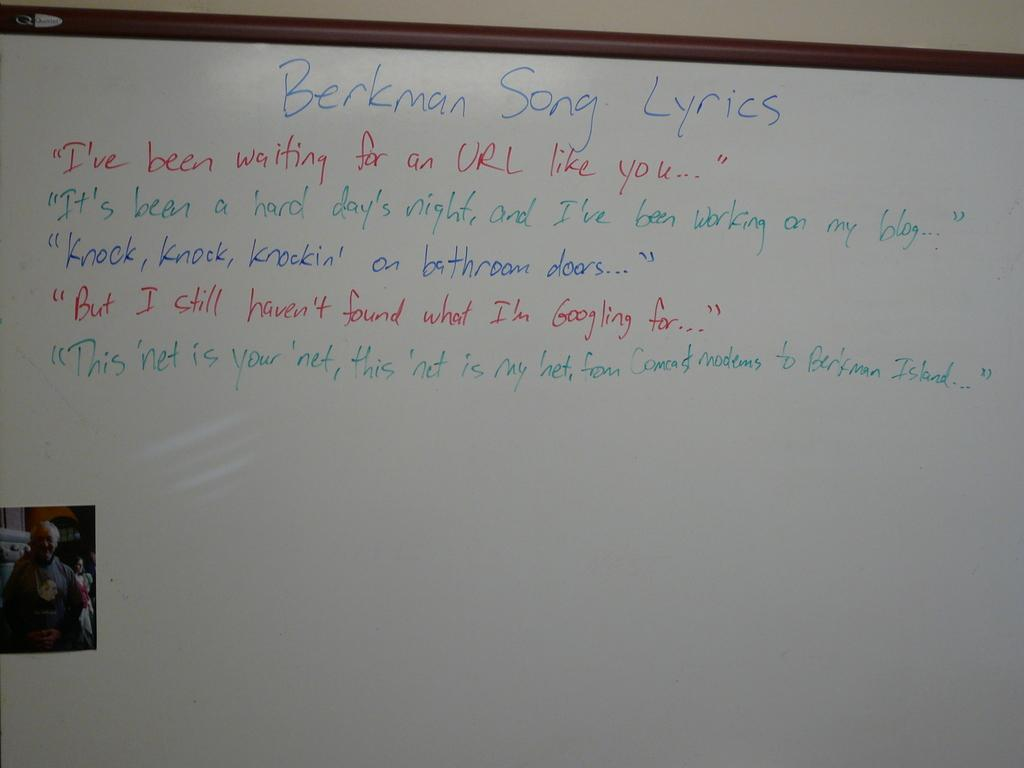<image>
Offer a succinct explanation of the picture presented. A white board is on a wall and has lyrics written on it. 